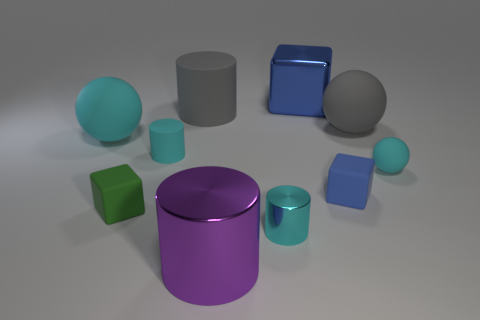There is a big metal thing that is in front of the cyan cylinder on the right side of the big purple thing; what number of large balls are right of it?
Your response must be concise. 1. Does the metal block have the same color as the small block that is right of the large blue metal cube?
Keep it short and to the point. Yes. There is a tiny shiny thing that is the same color as the small rubber cylinder; what shape is it?
Offer a very short reply. Cylinder. The large gray cylinder right of the cyan cylinder that is behind the tiny thing that is on the right side of the blue rubber block is made of what material?
Your answer should be very brief. Rubber. There is a small cyan matte thing left of the small matte sphere; is its shape the same as the green rubber thing?
Your response must be concise. No. What material is the tiny cyan cylinder behind the green block?
Offer a very short reply. Rubber. How many matte objects are either cyan cylinders or big objects?
Provide a succinct answer. 4. Are there any gray cylinders that have the same size as the purple cylinder?
Your answer should be very brief. Yes. Is the number of matte things behind the cyan matte cylinder greater than the number of small blue cubes?
Make the answer very short. Yes. What number of large things are cyan rubber balls or brown rubber cubes?
Your response must be concise. 1. 